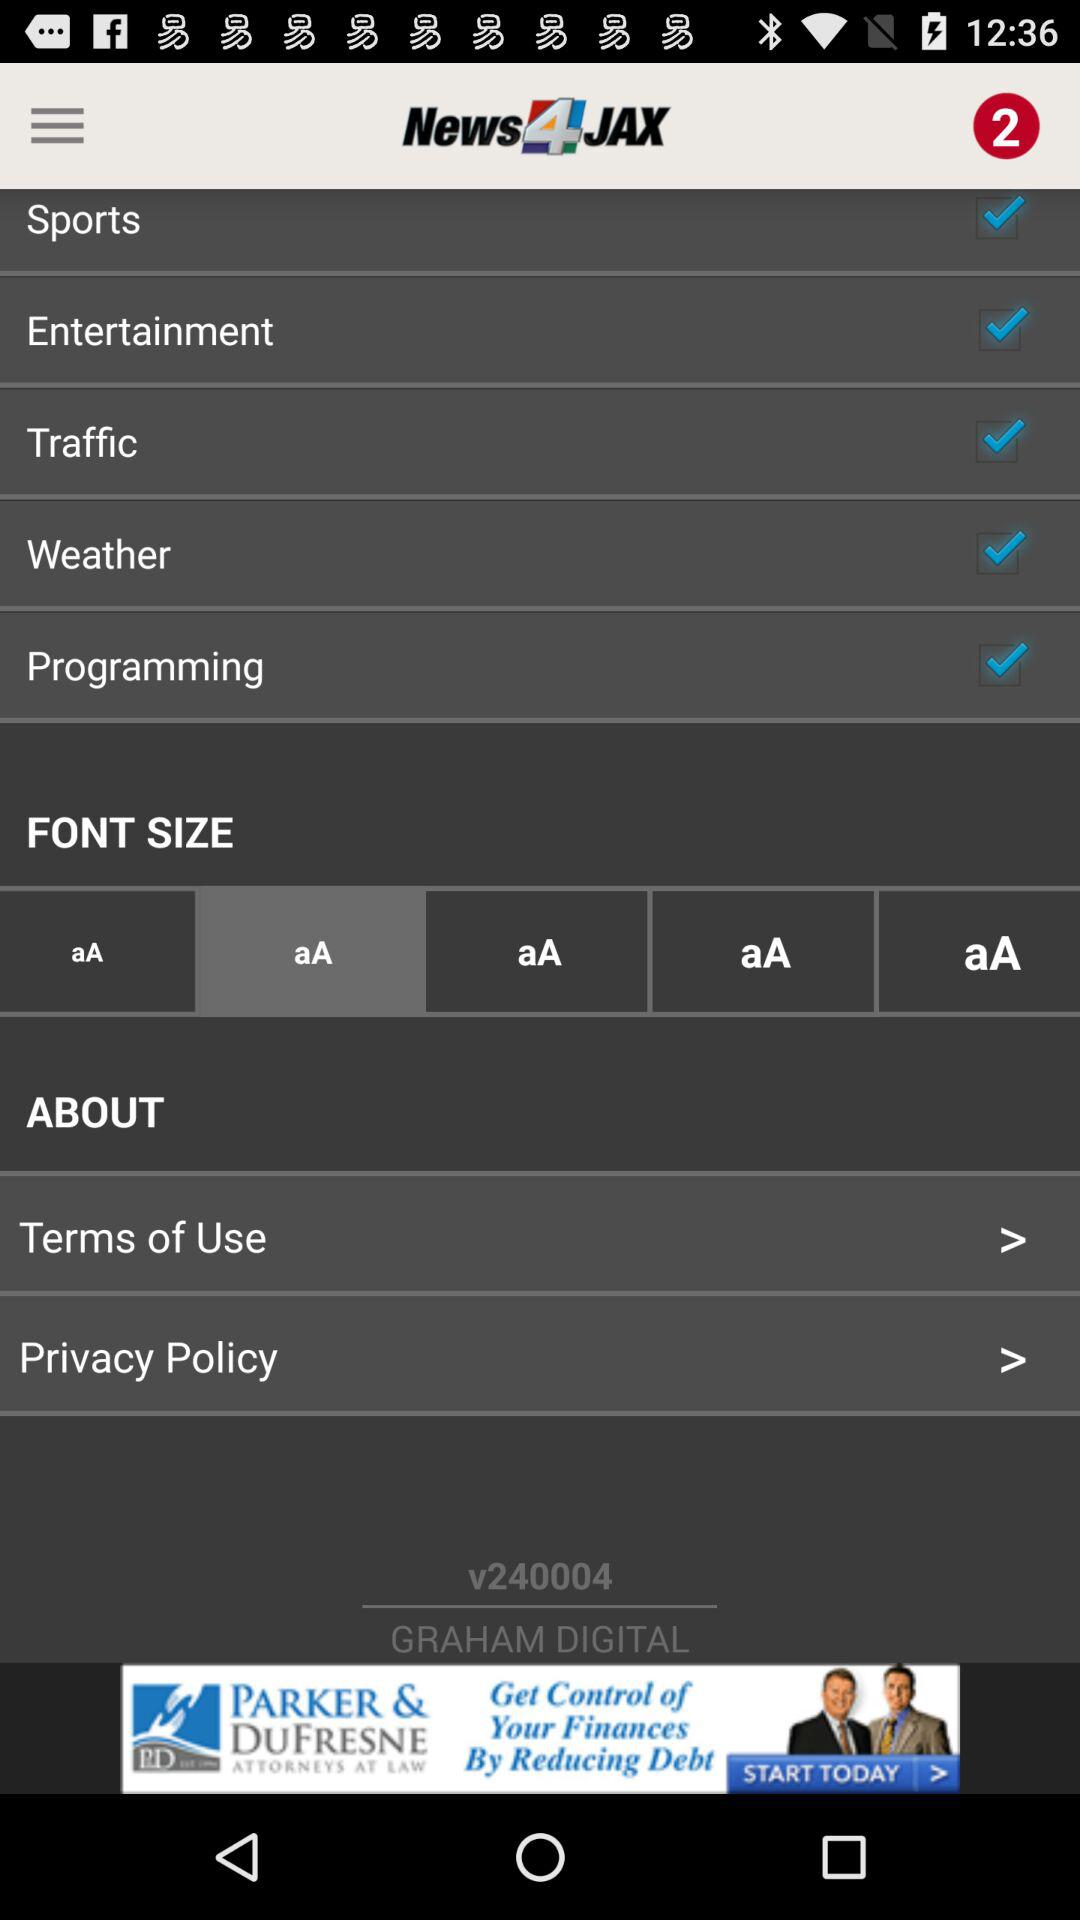Which font size is selected? The selected font size is "aA". 